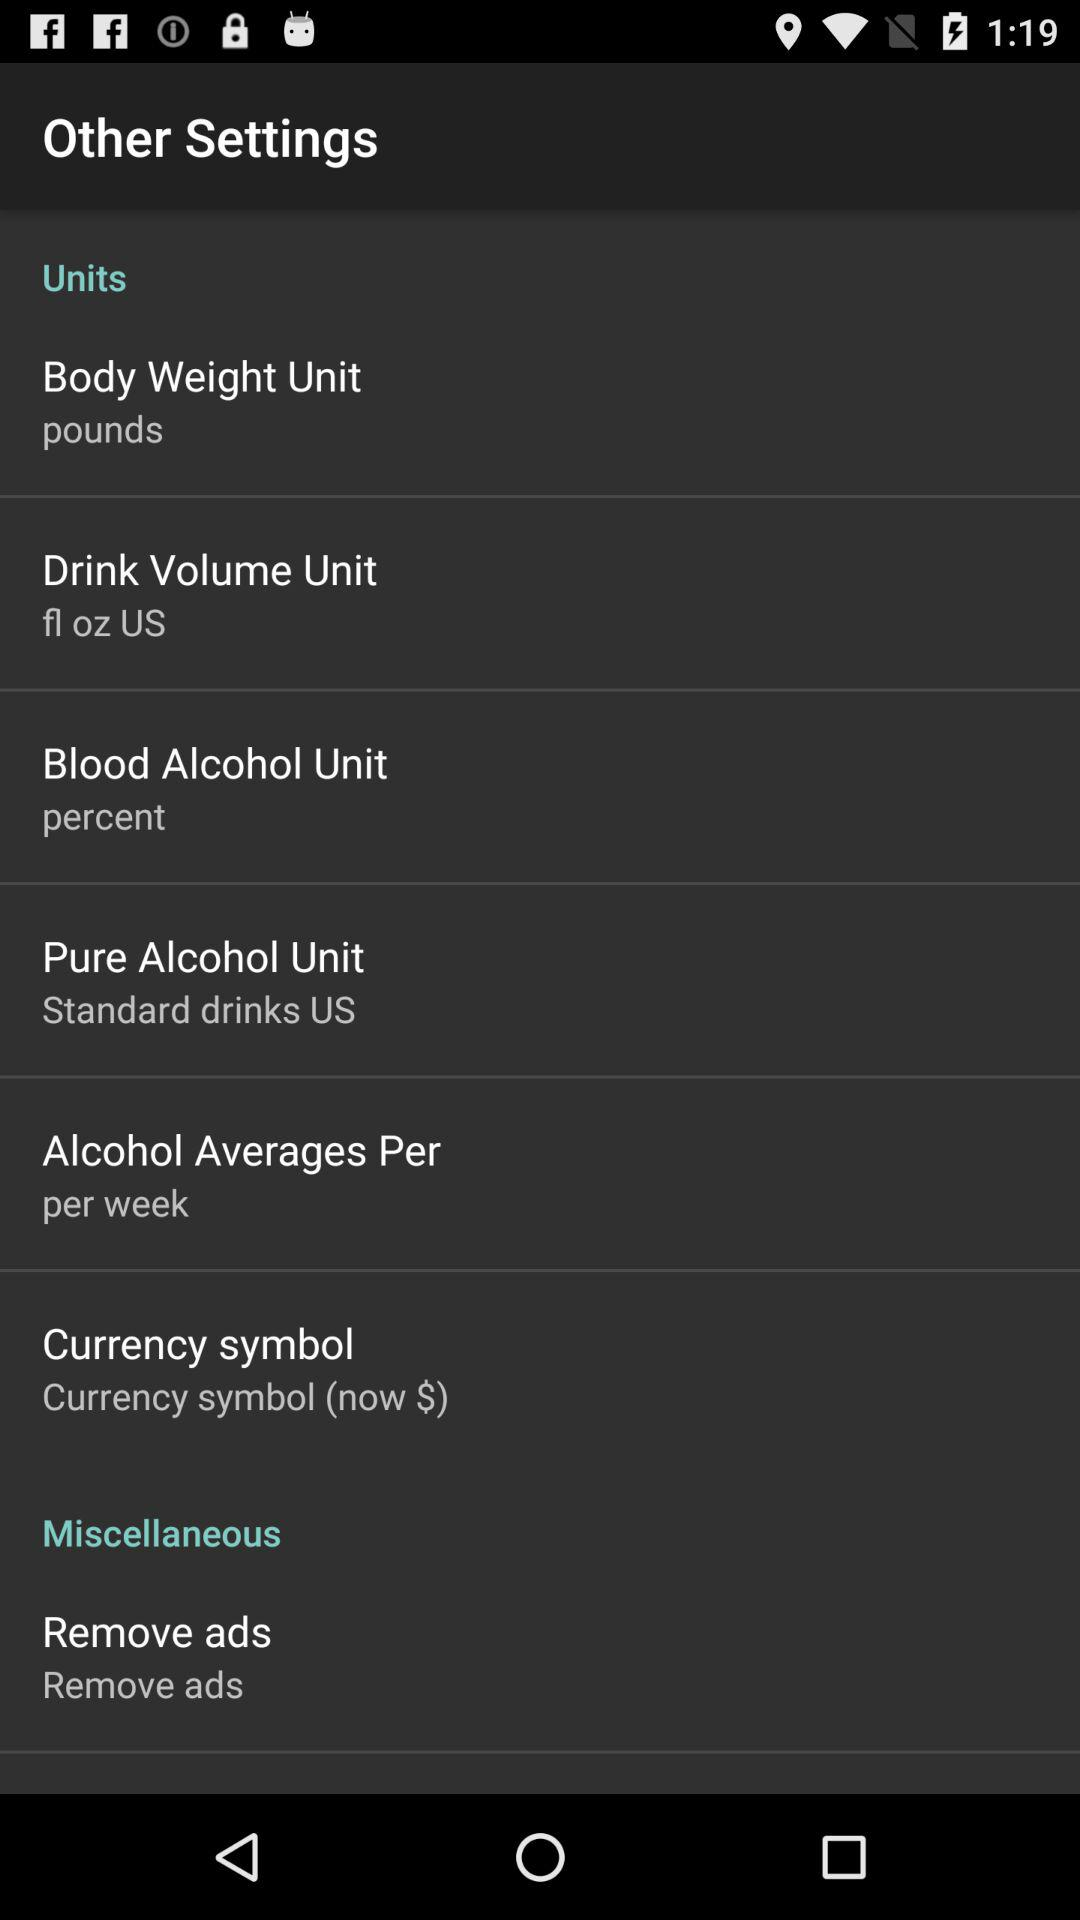What is the unit of blood alcohol? The unit of blood alcohol is percent. 